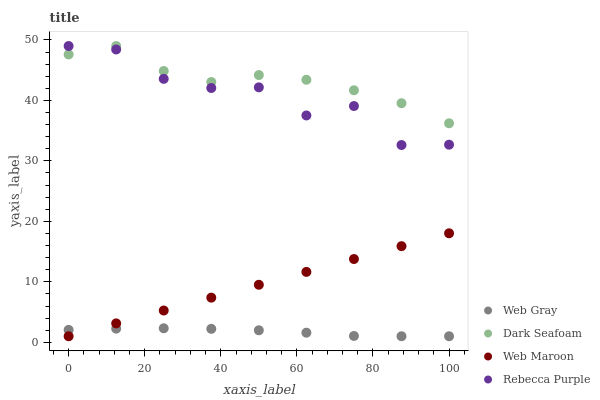Does Web Gray have the minimum area under the curve?
Answer yes or no. Yes. Does Dark Seafoam have the maximum area under the curve?
Answer yes or no. Yes. Does Web Maroon have the minimum area under the curve?
Answer yes or no. No. Does Web Maroon have the maximum area under the curve?
Answer yes or no. No. Is Web Maroon the smoothest?
Answer yes or no. Yes. Is Rebecca Purple the roughest?
Answer yes or no. Yes. Is Web Gray the smoothest?
Answer yes or no. No. Is Web Gray the roughest?
Answer yes or no. No. Does Web Gray have the lowest value?
Answer yes or no. Yes. Does Rebecca Purple have the lowest value?
Answer yes or no. No. Does Rebecca Purple have the highest value?
Answer yes or no. Yes. Does Web Maroon have the highest value?
Answer yes or no. No. Is Web Gray less than Dark Seafoam?
Answer yes or no. Yes. Is Rebecca Purple greater than Web Maroon?
Answer yes or no. Yes. Does Rebecca Purple intersect Dark Seafoam?
Answer yes or no. Yes. Is Rebecca Purple less than Dark Seafoam?
Answer yes or no. No. Is Rebecca Purple greater than Dark Seafoam?
Answer yes or no. No. Does Web Gray intersect Dark Seafoam?
Answer yes or no. No. 